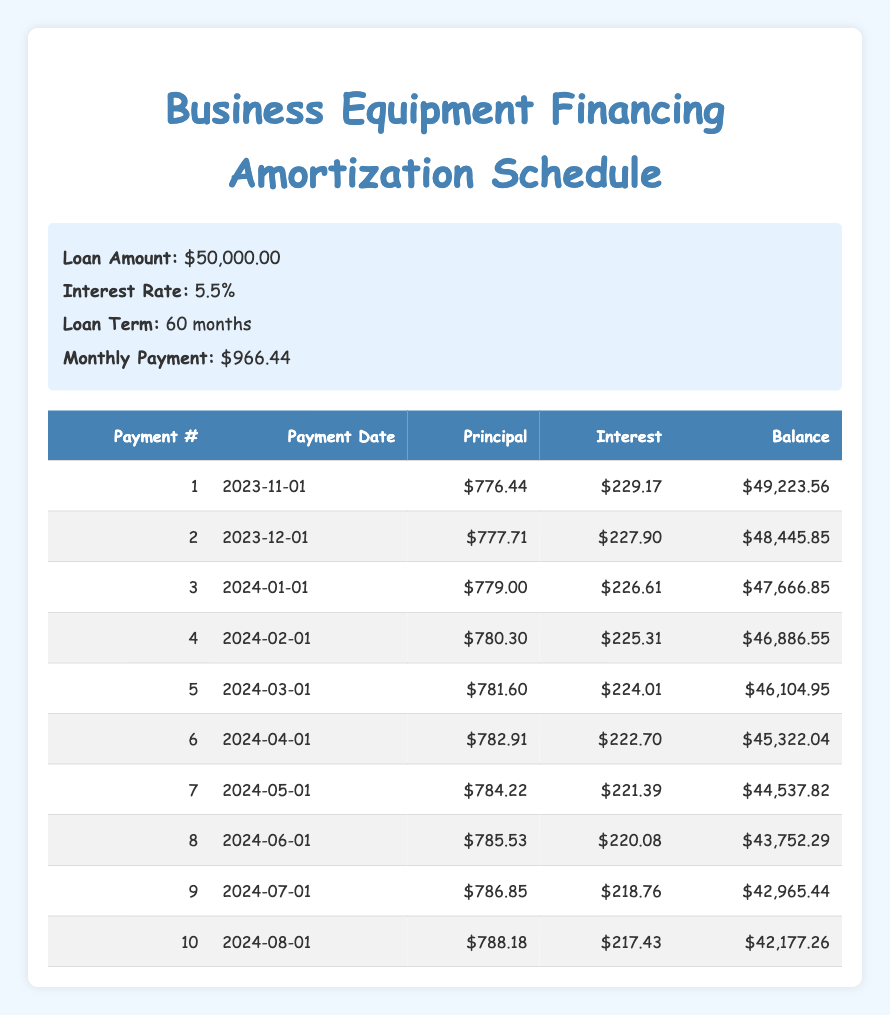What is the total loan amount for the business equipment financing? The loan amount mentioned is $50,000.00 in the loan details section, which directly states the total amount financed.
Answer: 50000 How much is the interest payment for the first month? The first-month interest payment is listed as $229.17 in the amortization schedule under the interest column for payment number 1.
Answer: 229.17 What is the remaining balance after the fifth payment? After the fifth payment, the remaining balance is $46,104.95, which is indicated in the balance column for payment number 5 in the table.
Answer: 46104.95 What is the total principal paid in the first 10 payments? To find the total principal paid, sum the principal payments for the first 10 payments: 776.44 + 777.71 + 779.00 + 780.30 + 781.60 + 782.91 + 784.22 + 785.53 + 786.85 + 788.18 = 7,660.80.
Answer: 7660.80 Is the interest payment for the second payment higher than the first payment? The interest payment for the second payment is $227.90, and the first payment's interest is $229.17. Since $227.90 is less than $229.17, the answer is no.
Answer: No What is the average monthly principal payment for the first 5 months? To find the average principal payment for the first 5 months, sum the principal payments for those payments: 776.44 + 777.71 + 779.00 + 780.30 + 781.60 = 3,895.05. Then divide by 5, which gives 3,895.05 / 5 = 779.01.
Answer: 779.01 How much total interest was paid in the first three months? The total interest paid in the first three months can be calculated by summing the interest payments for those months: 229.17 + 227.90 + 226.61 = 683.68.
Answer: 683.68 Which payment has the highest principal payment amount? Looking at the table, the 10th payment has the highest principal payment, which is $788.18. This is the largest value in the principal column across the first 10 payments.
Answer: 788.18 Is the remaining balance after the seventh payment less than after the fourth payment? The remaining balance after the seventh payment is $44,537.82, while after the fourth payment, it's $46,886.55. Since $44,537.82 is less than $46,886.55, the answer is yes.
Answer: Yes 